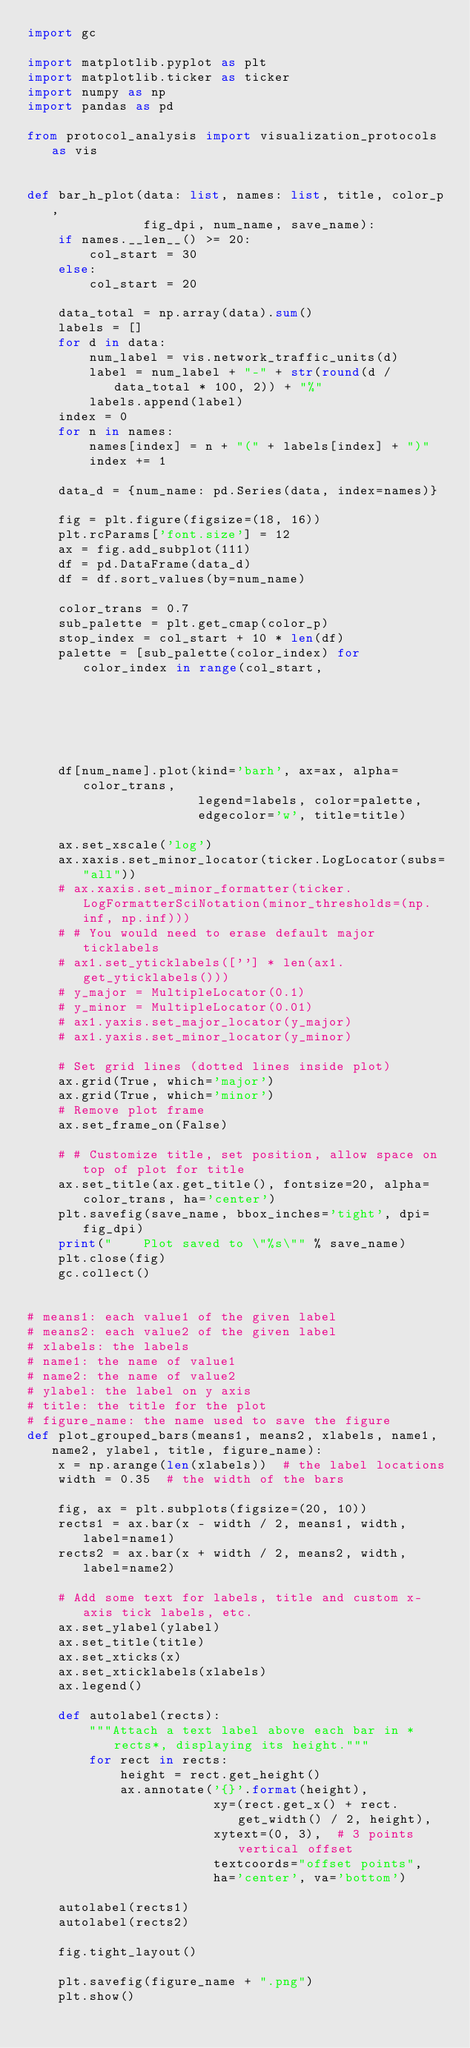Convert code to text. <code><loc_0><loc_0><loc_500><loc_500><_Python_>import gc

import matplotlib.pyplot as plt
import matplotlib.ticker as ticker
import numpy as np
import pandas as pd

from protocol_analysis import visualization_protocols as vis


def bar_h_plot(data: list, names: list, title, color_p,
               fig_dpi, num_name, save_name):
    if names.__len__() >= 20:
        col_start = 30
    else:
        col_start = 20

    data_total = np.array(data).sum()
    labels = []
    for d in data:
        num_label = vis.network_traffic_units(d)
        label = num_label + "-" + str(round(d / data_total * 100, 2)) + "%"
        labels.append(label)
    index = 0
    for n in names:
        names[index] = n + "(" + labels[index] + ")"
        index += 1

    data_d = {num_name: pd.Series(data, index=names)}

    fig = plt.figure(figsize=(18, 16))
    plt.rcParams['font.size'] = 12
    ax = fig.add_subplot(111)
    df = pd.DataFrame(data_d)
    df = df.sort_values(by=num_name)

    color_trans = 0.7
    sub_palette = plt.get_cmap(color_p)
    stop_index = col_start + 10 * len(df)
    palette = [sub_palette(color_index) for color_index in range(col_start,
                                                                 stop_index,
                                                                 10)]
    df[num_name].plot(kind='barh', ax=ax, alpha=color_trans,
                      legend=labels, color=palette,
                      edgecolor='w', title=title)

    ax.set_xscale('log')
    ax.xaxis.set_minor_locator(ticker.LogLocator(subs="all"))
    # ax.xaxis.set_minor_formatter(ticker.LogFormatterSciNotation(minor_thresholds=(np.inf, np.inf)))
    # # You would need to erase default major ticklabels
    # ax1.set_yticklabels([''] * len(ax1.get_yticklabels()))
    # y_major = MultipleLocator(0.1)
    # y_minor = MultipleLocator(0.01)
    # ax1.yaxis.set_major_locator(y_major)
    # ax1.yaxis.set_minor_locator(y_minor)

    # Set grid lines (dotted lines inside plot)
    ax.grid(True, which='major')
    ax.grid(True, which='minor')
    # Remove plot frame
    ax.set_frame_on(False)

    # # Customize title, set position, allow space on top of plot for title
    ax.set_title(ax.get_title(), fontsize=20, alpha=color_trans, ha='center')
    plt.savefig(save_name, bbox_inches='tight', dpi=fig_dpi)
    print("    Plot saved to \"%s\"" % save_name)
    plt.close(fig)
    gc.collect()


# means1: each value1 of the given label
# means2: each value2 of the given label
# xlabels: the labels
# name1: the name of value1
# name2: the name of value2
# ylabel: the label on y axis
# title: the title for the plot
# figure_name: the name used to save the figure
def plot_grouped_bars(means1, means2, xlabels, name1, name2, ylabel, title, figure_name):
    x = np.arange(len(xlabels))  # the label locations
    width = 0.35  # the width of the bars

    fig, ax = plt.subplots(figsize=(20, 10))
    rects1 = ax.bar(x - width / 2, means1, width, label=name1)
    rects2 = ax.bar(x + width / 2, means2, width, label=name2)

    # Add some text for labels, title and custom x-axis tick labels, etc.
    ax.set_ylabel(ylabel)
    ax.set_title(title)
    ax.set_xticks(x)
    ax.set_xticklabels(xlabels)
    ax.legend()

    def autolabel(rects):
        """Attach a text label above each bar in *rects*, displaying its height."""
        for rect in rects:
            height = rect.get_height()
            ax.annotate('{}'.format(height),
                        xy=(rect.get_x() + rect.get_width() / 2, height),
                        xytext=(0, 3),  # 3 points vertical offset
                        textcoords="offset points",
                        ha='center', va='bottom')

    autolabel(rects1)
    autolabel(rects2)

    fig.tight_layout()

    plt.savefig(figure_name + ".png")
    plt.show()
</code> 